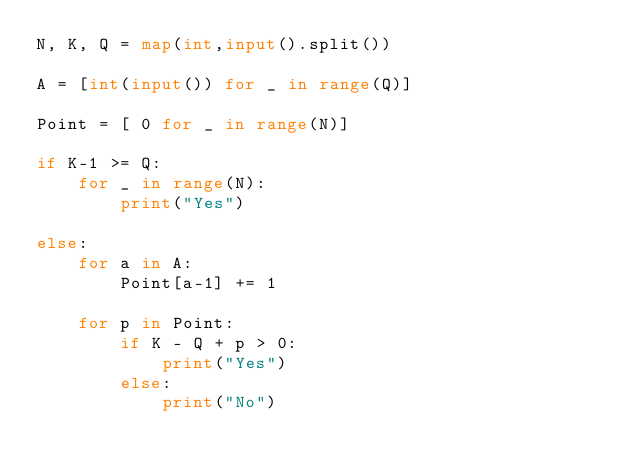Convert code to text. <code><loc_0><loc_0><loc_500><loc_500><_Python_>N, K, Q = map(int,input().split())

A = [int(input()) for _ in range(Q)]

Point = [ 0 for _ in range(N)]

if K-1 >= Q:
    for _ in range(N):
        print("Yes")

else:
    for a in A:
        Point[a-1] += 1

    for p in Point:
        if K - Q + p > 0:
            print("Yes")
        else:
            print("No")</code> 